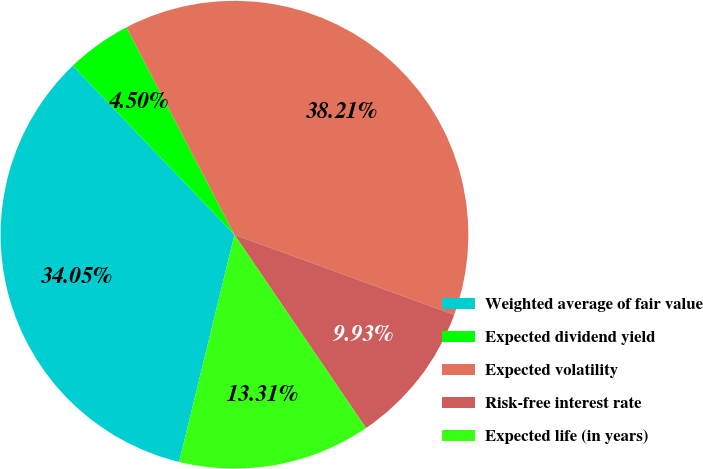Convert chart to OTSL. <chart><loc_0><loc_0><loc_500><loc_500><pie_chart><fcel>Weighted average of fair value<fcel>Expected dividend yield<fcel>Expected volatility<fcel>Risk-free interest rate<fcel>Expected life (in years)<nl><fcel>34.05%<fcel>4.5%<fcel>38.21%<fcel>9.93%<fcel>13.31%<nl></chart> 